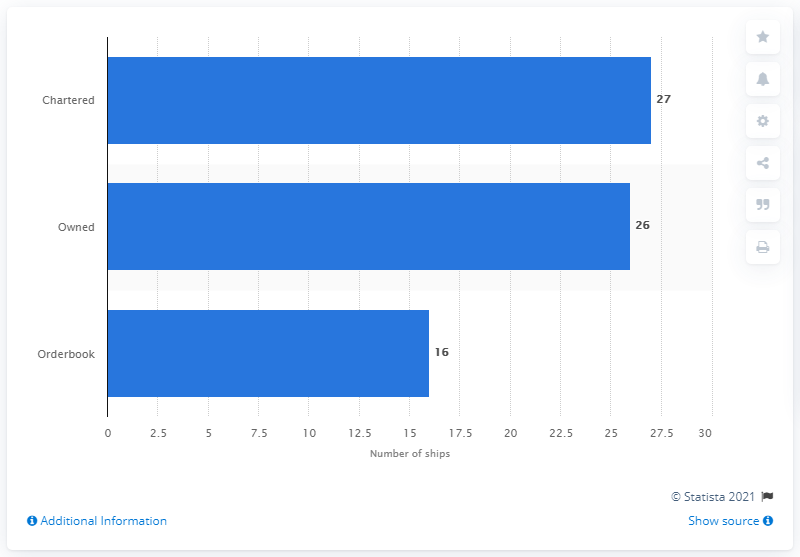Highlight a few significant elements in this photo. On December 3, 2014, the United Arab Shipping Company's order book contained 16 ships. 